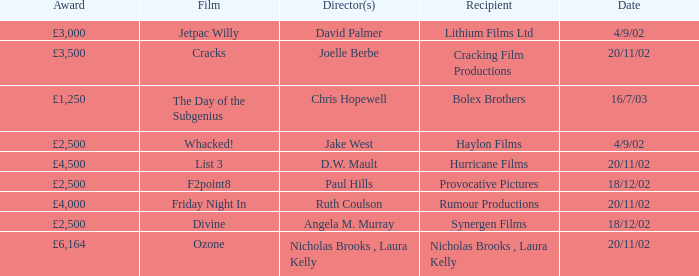Could you parse the entire table? {'header': ['Award', 'Film', 'Director(s)', 'Recipient', 'Date'], 'rows': [['£3,000', 'Jetpac Willy', 'David Palmer', 'Lithium Films Ltd', '4/9/02'], ['£3,500', 'Cracks', 'Joelle Berbe', 'Cracking Film Productions', '20/11/02'], ['£1,250', 'The Day of the Subgenius', 'Chris Hopewell', 'Bolex Brothers', '16/7/03'], ['£2,500', 'Whacked!', 'Jake West', 'Haylon Films', '4/9/02'], ['£4,500', 'List 3', 'D.W. Mault', 'Hurricane Films', '20/11/02'], ['£2,500', 'F2point8', 'Paul Hills', 'Provocative Pictures', '18/12/02'], ['£4,000', 'Friday Night In', 'Ruth Coulson', 'Rumour Productions', '20/11/02'], ['£2,500', 'Divine', 'Angela M. Murray', 'Synergen Films', '18/12/02'], ['£6,164', 'Ozone', 'Nicholas Brooks , Laura Kelly', 'Nicholas Brooks , Laura Kelly', '20/11/02']]} Who directed a film for Cracking Film Productions? Joelle Berbe. 